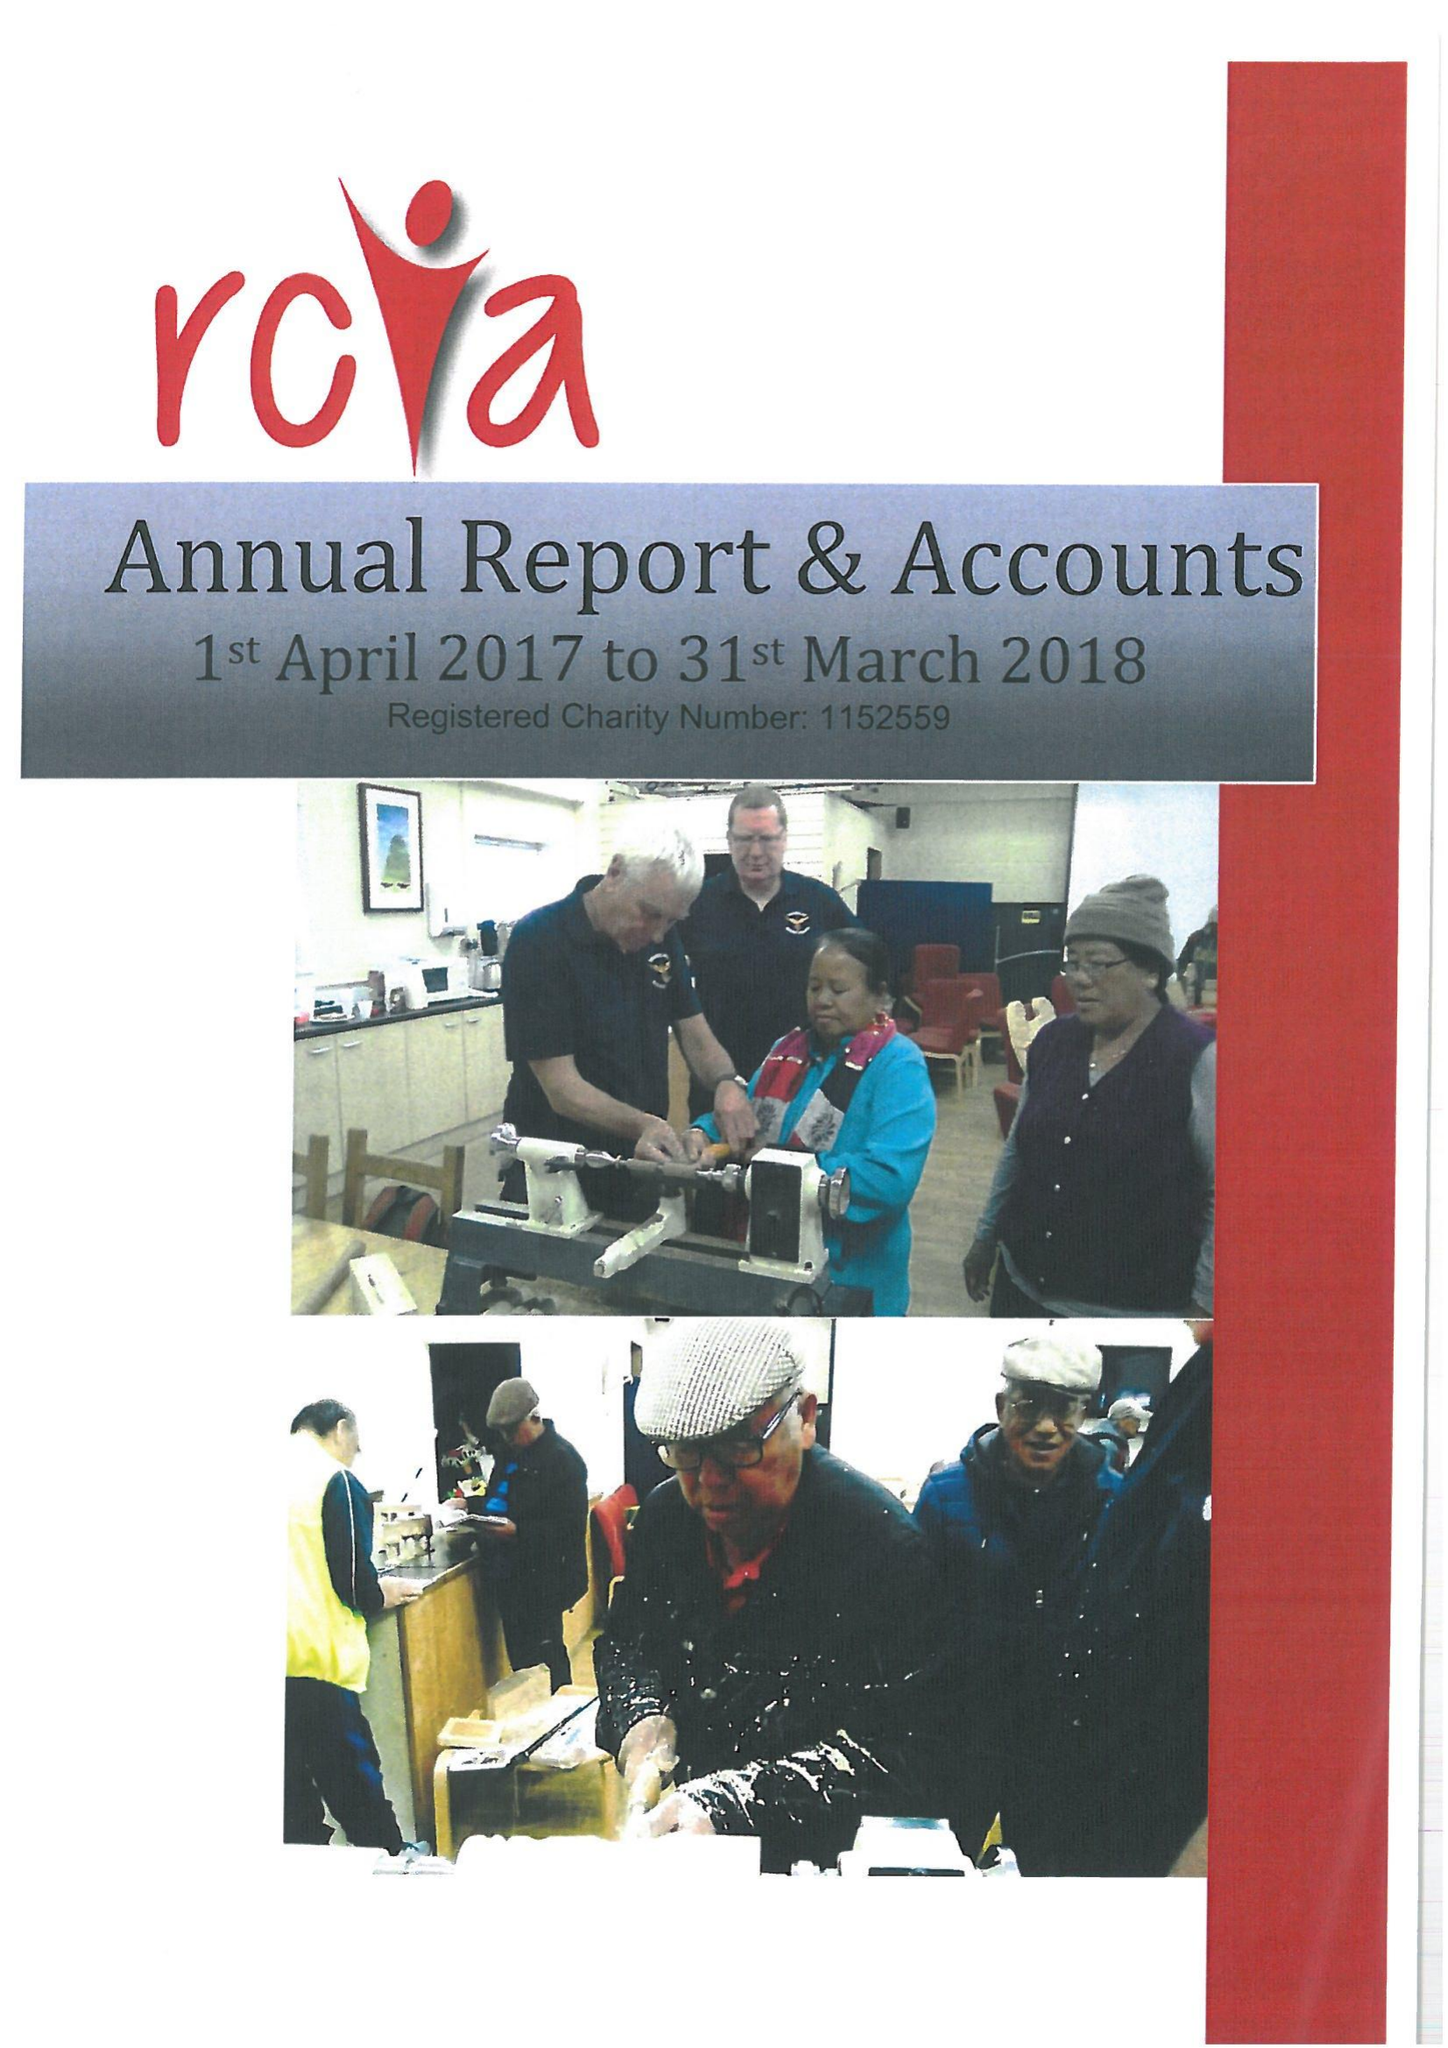What is the value for the report_date?
Answer the question using a single word or phrase. 2018-03-31 